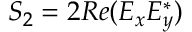<formula> <loc_0><loc_0><loc_500><loc_500>S _ { 2 } = 2 R e ( E _ { x } E _ { y } ^ { * } )</formula> 